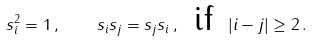<formula> <loc_0><loc_0><loc_500><loc_500>s _ { i } ^ { 2 } = 1 \, , \quad s _ { i } s _ { j } = s _ { j } s _ { i } \, , \ \, \text {if} \ \, | i - j | \geq 2 \, .</formula> 